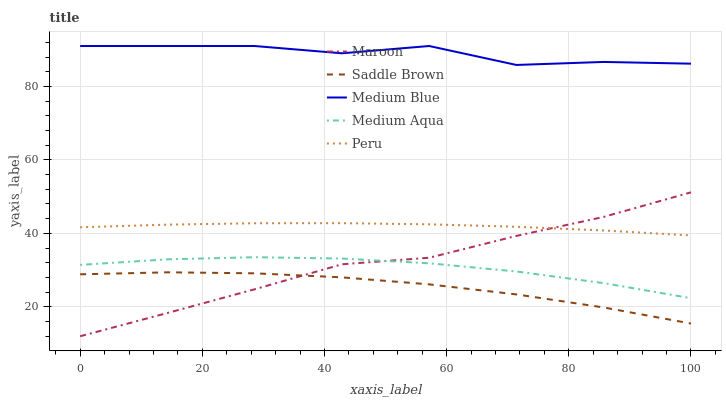Does Saddle Brown have the minimum area under the curve?
Answer yes or no. Yes. Does Medium Blue have the maximum area under the curve?
Answer yes or no. Yes. Does Medium Aqua have the minimum area under the curve?
Answer yes or no. No. Does Medium Aqua have the maximum area under the curve?
Answer yes or no. No. Is Peru the smoothest?
Answer yes or no. Yes. Is Medium Blue the roughest?
Answer yes or no. Yes. Is Medium Aqua the smoothest?
Answer yes or no. No. Is Medium Aqua the roughest?
Answer yes or no. No. Does Maroon have the lowest value?
Answer yes or no. Yes. Does Medium Aqua have the lowest value?
Answer yes or no. No. Does Medium Blue have the highest value?
Answer yes or no. Yes. Does Medium Aqua have the highest value?
Answer yes or no. No. Is Maroon less than Medium Blue?
Answer yes or no. Yes. Is Medium Aqua greater than Saddle Brown?
Answer yes or no. Yes. Does Maroon intersect Peru?
Answer yes or no. Yes. Is Maroon less than Peru?
Answer yes or no. No. Is Maroon greater than Peru?
Answer yes or no. No. Does Maroon intersect Medium Blue?
Answer yes or no. No. 